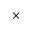<formula> <loc_0><loc_0><loc_500><loc_500>\times</formula> 